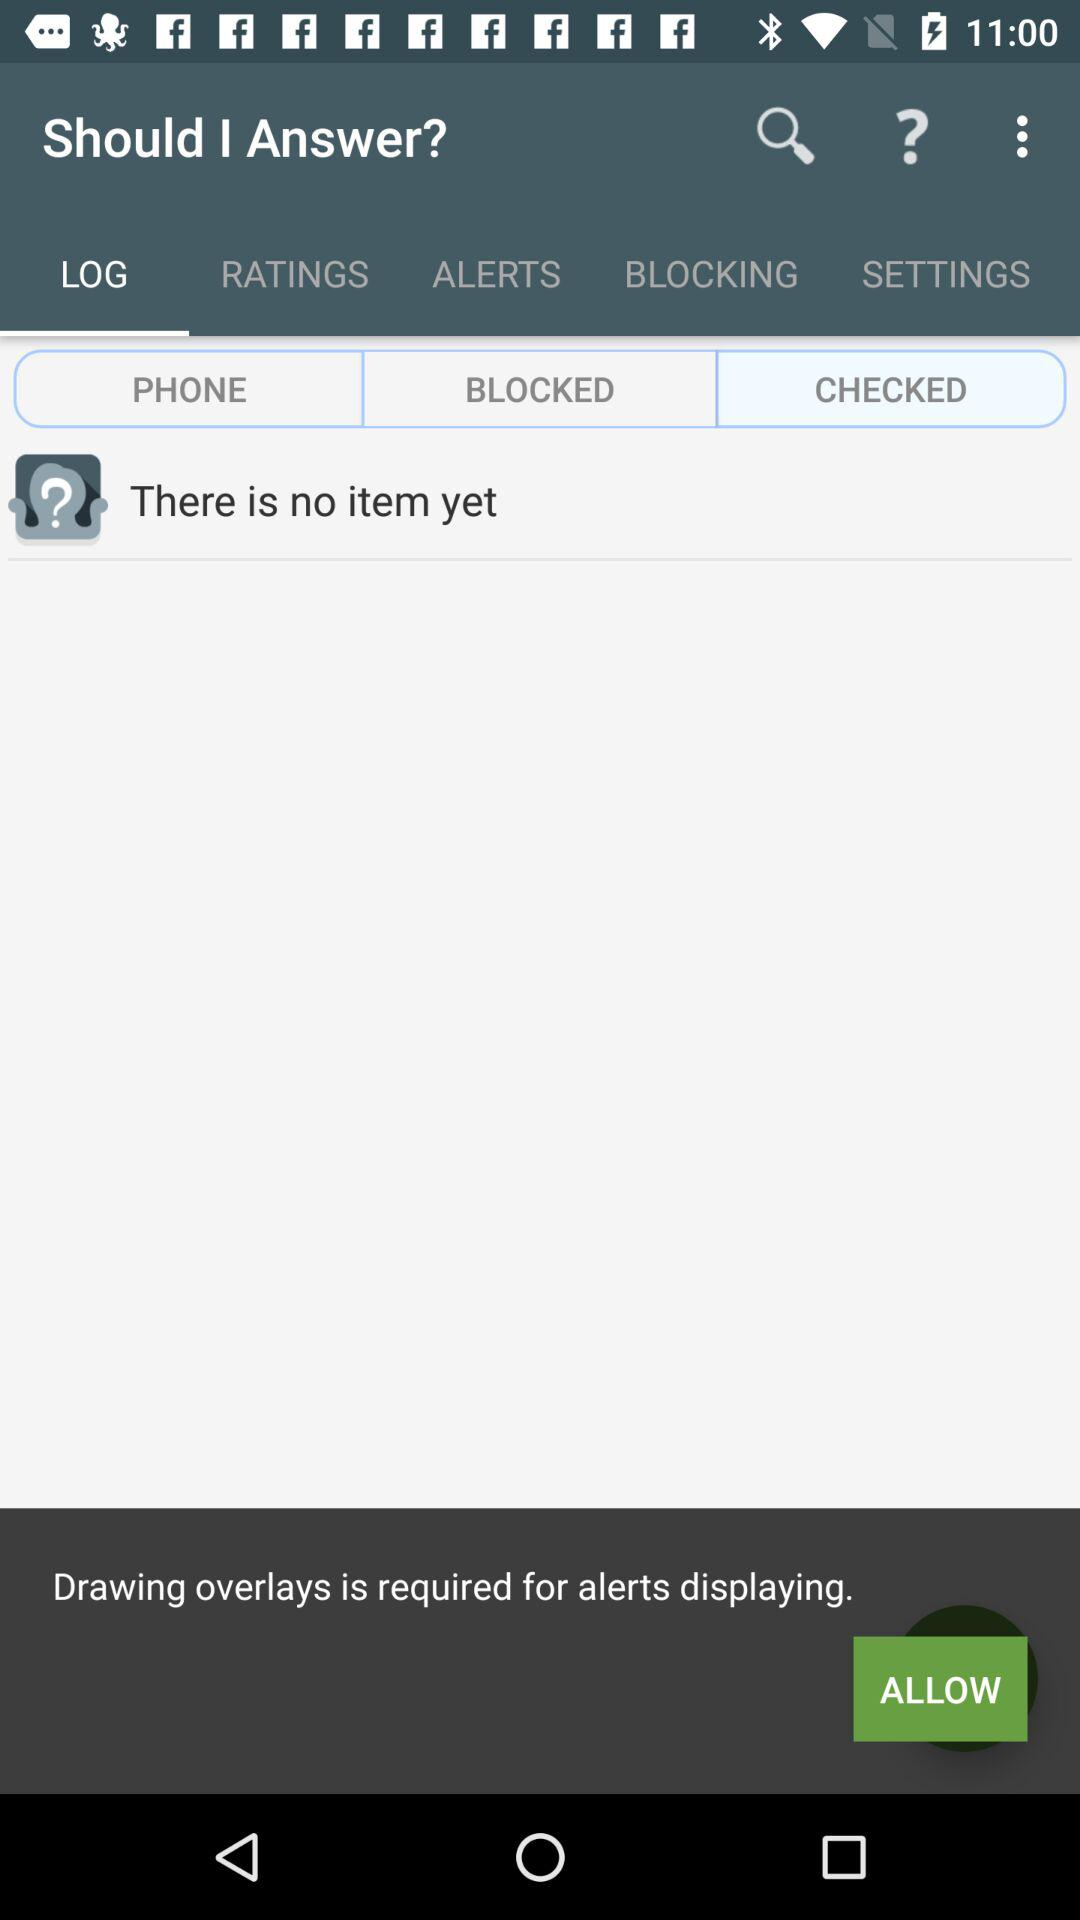Which is the selected tab? The selected tab is "LOG". 